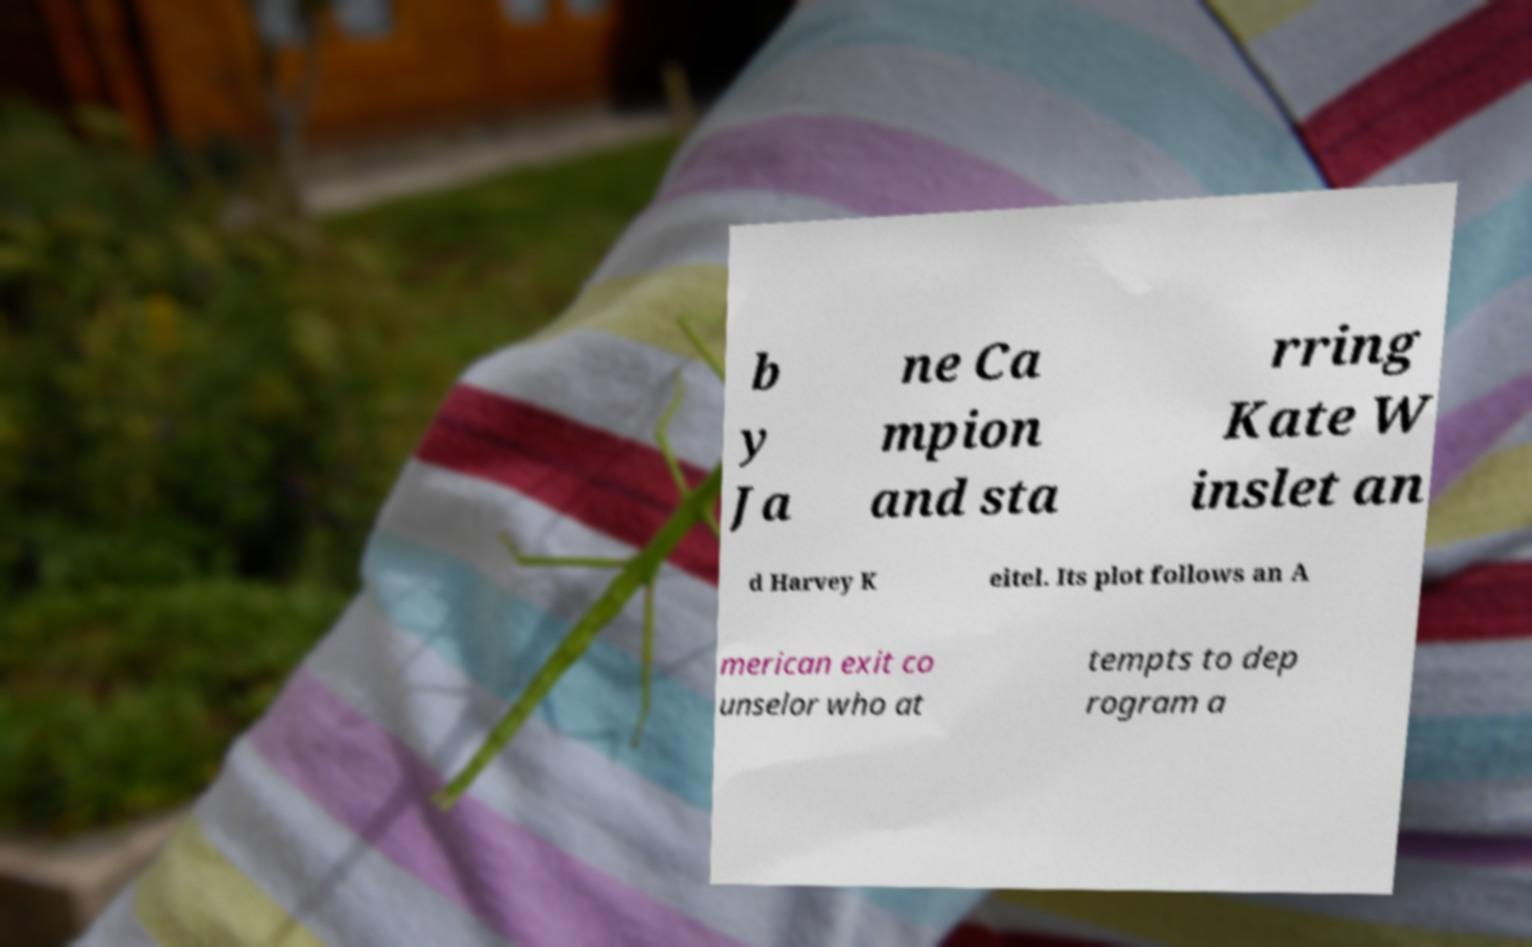Please read and relay the text visible in this image. What does it say? b y Ja ne Ca mpion and sta rring Kate W inslet an d Harvey K eitel. Its plot follows an A merican exit co unselor who at tempts to dep rogram a 